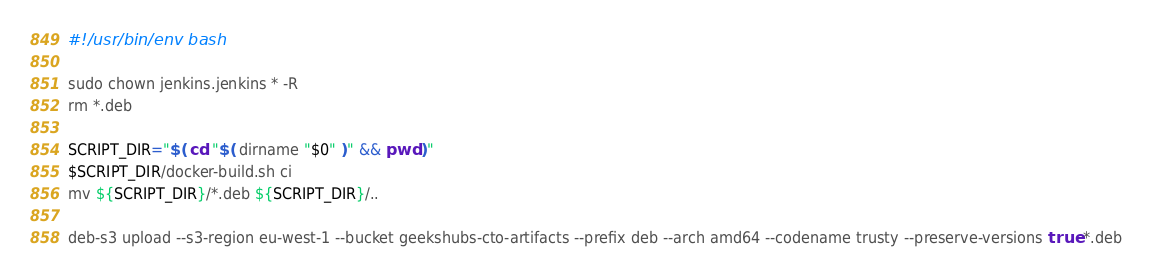<code> <loc_0><loc_0><loc_500><loc_500><_Bash_>#!/usr/bin/env bash

sudo chown jenkins.jenkins * -R
rm *.deb

SCRIPT_DIR="$( cd "$( dirname "$0" )" && pwd )"
$SCRIPT_DIR/docker-build.sh ci
mv ${SCRIPT_DIR}/*.deb ${SCRIPT_DIR}/..

deb-s3 upload --s3-region eu-west-1 --bucket geekshubs-cto-artifacts --prefix deb --arch amd64 --codename trusty --preserve-versions true *.deb

</code> 